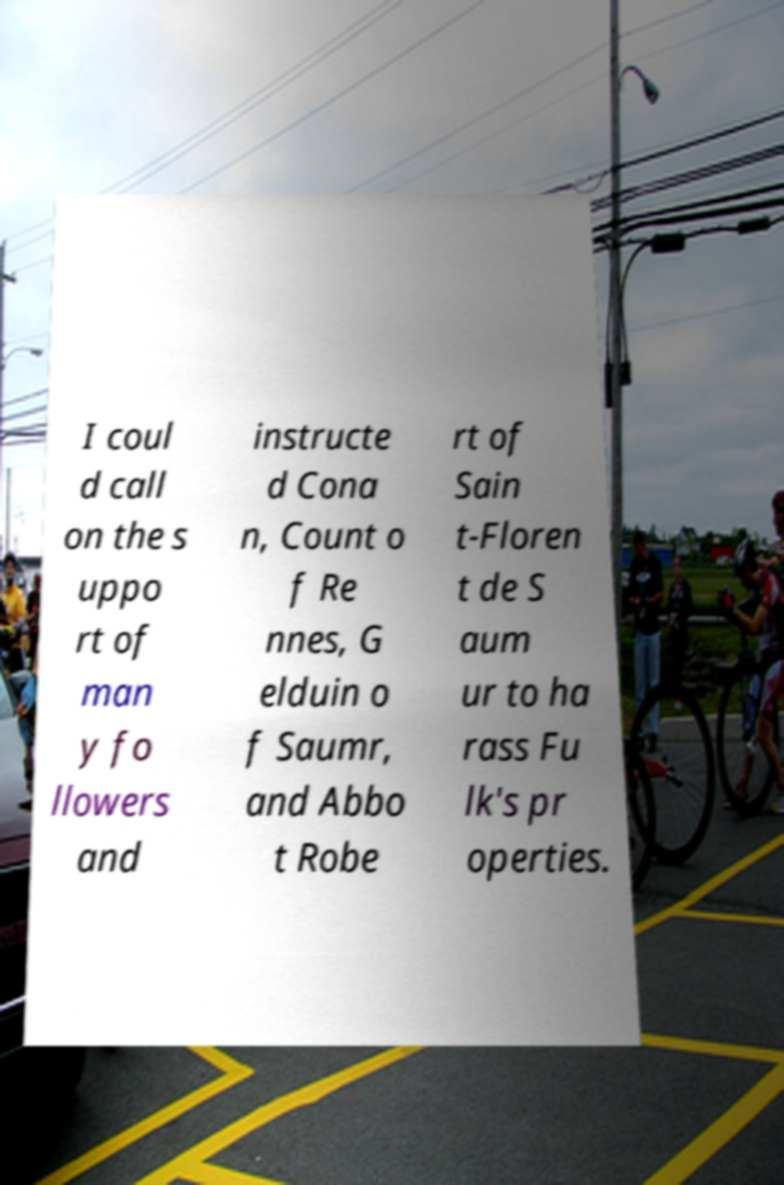Can you accurately transcribe the text from the provided image for me? I coul d call on the s uppo rt of man y fo llowers and instructe d Cona n, Count o f Re nnes, G elduin o f Saumr, and Abbo t Robe rt of Sain t-Floren t de S aum ur to ha rass Fu lk's pr operties. 